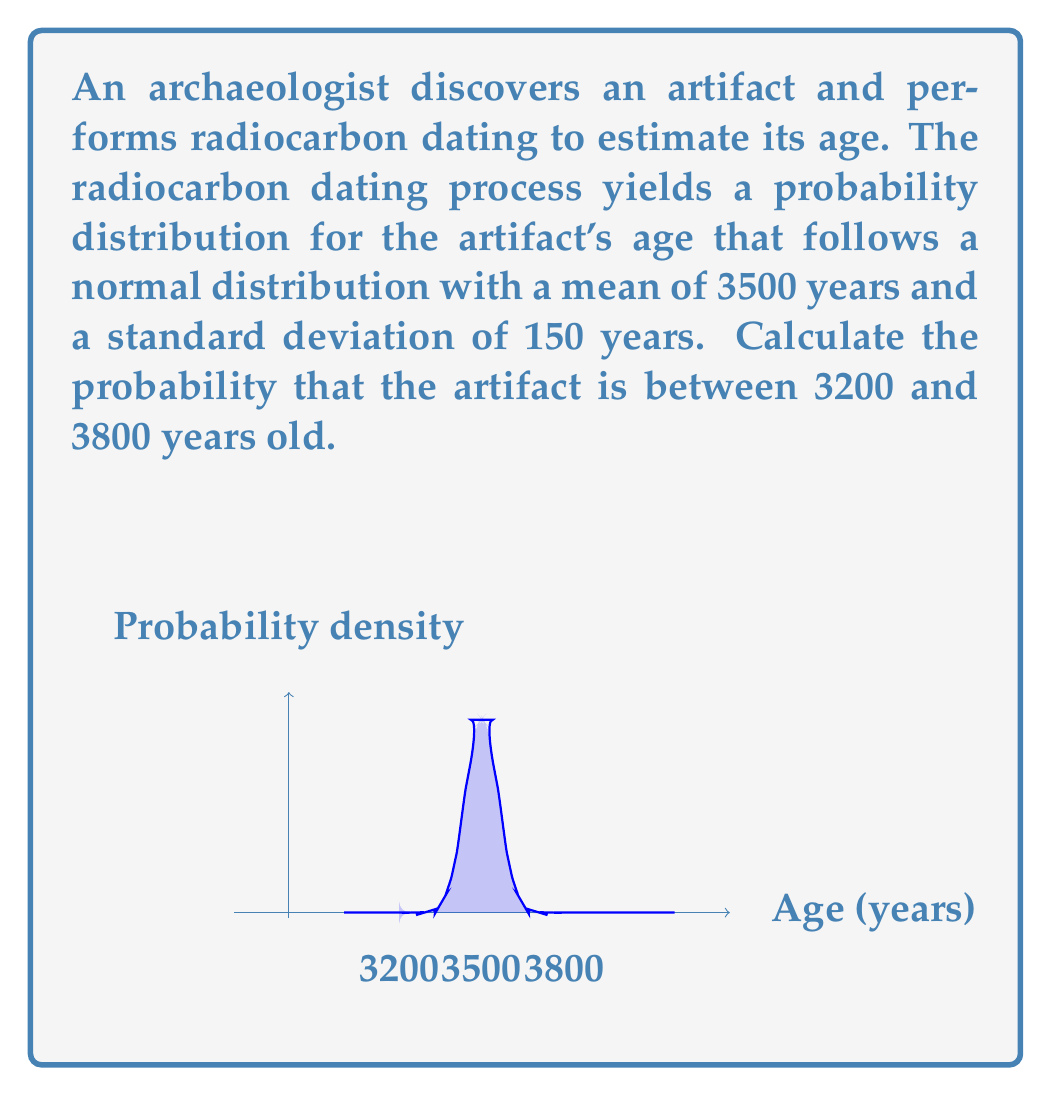Provide a solution to this math problem. To solve this problem, we need to use the properties of the normal distribution and the concept of z-scores. Let's approach this step-by-step:

1) We are given that the age follows a normal distribution with:
   $\mu = 3500$ years (mean)
   $\sigma = 150$ years (standard deviation)

2) We need to find the probability that the age is between 3200 and 3800 years.

3) First, let's calculate the z-scores for these boundaries:

   For 3200 years: $z_1 = \frac{3200 - 3500}{150} = -2$
   For 3800 years: $z_2 = \frac{3800 - 3500}{150} = 2$

4) Now, we need to find the area under the standard normal curve between $z = -2$ and $z = 2$.

5) This is equivalent to finding $P(-2 < Z < 2)$, where $Z$ is a standard normal random variable.

6) Due to the symmetry of the normal distribution, this is the same as:

   $P(-2 < Z < 2) = P(Z < 2) - P(Z < -2) = 2P(Z < 2) - 1$

7) Using a standard normal table or calculator:

   $P(Z < 2) \approx 0.9772$

8) Therefore:

   $P(-2 < Z < 2) = 2(0.9772) - 1 = 0.9544$

9) This means there is approximately a 95.44% chance that the artifact is between 3200 and 3800 years old.
Answer: 0.9544 or 95.44% 